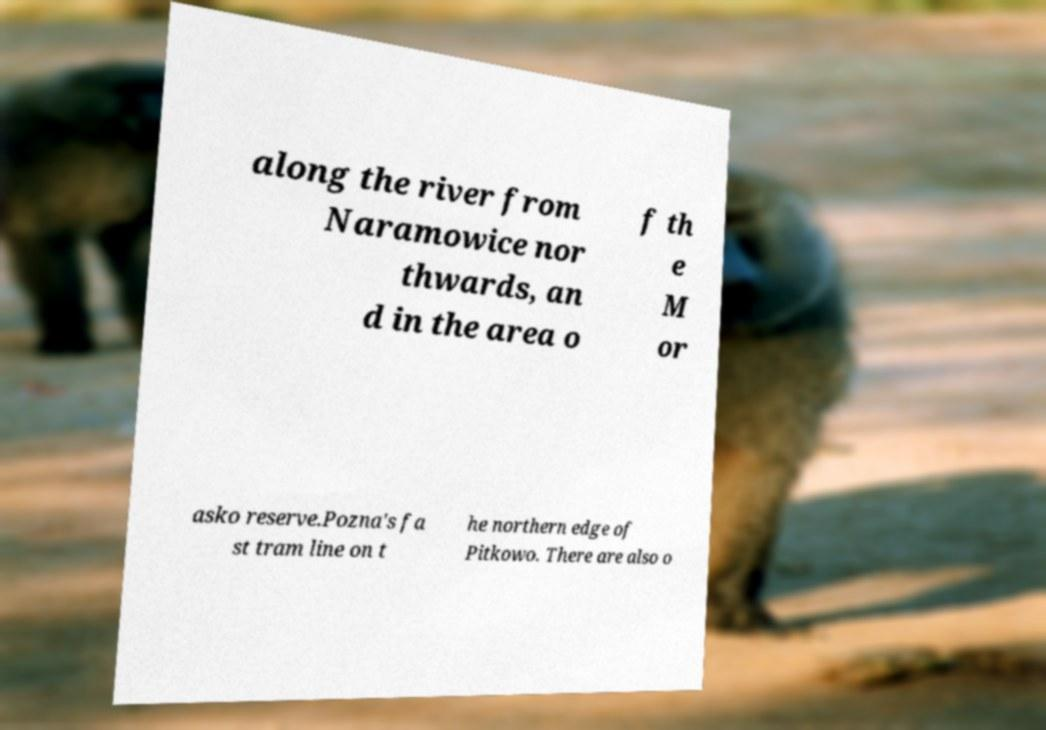Could you assist in decoding the text presented in this image and type it out clearly? along the river from Naramowice nor thwards, an d in the area o f th e M or asko reserve.Pozna's fa st tram line on t he northern edge of Pitkowo. There are also o 